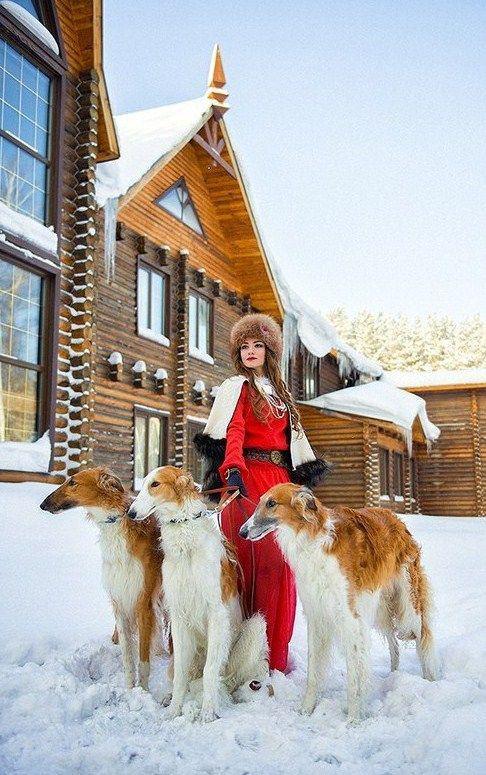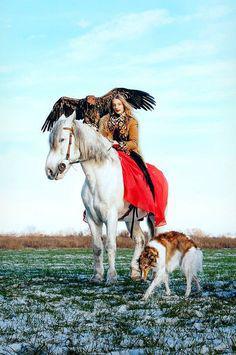The first image is the image on the left, the second image is the image on the right. Evaluate the accuracy of this statement regarding the images: "In image there is a woman dressed in red walking three Russian Wolfhounds in the snow.". Is it true? Answer yes or no. Yes. 